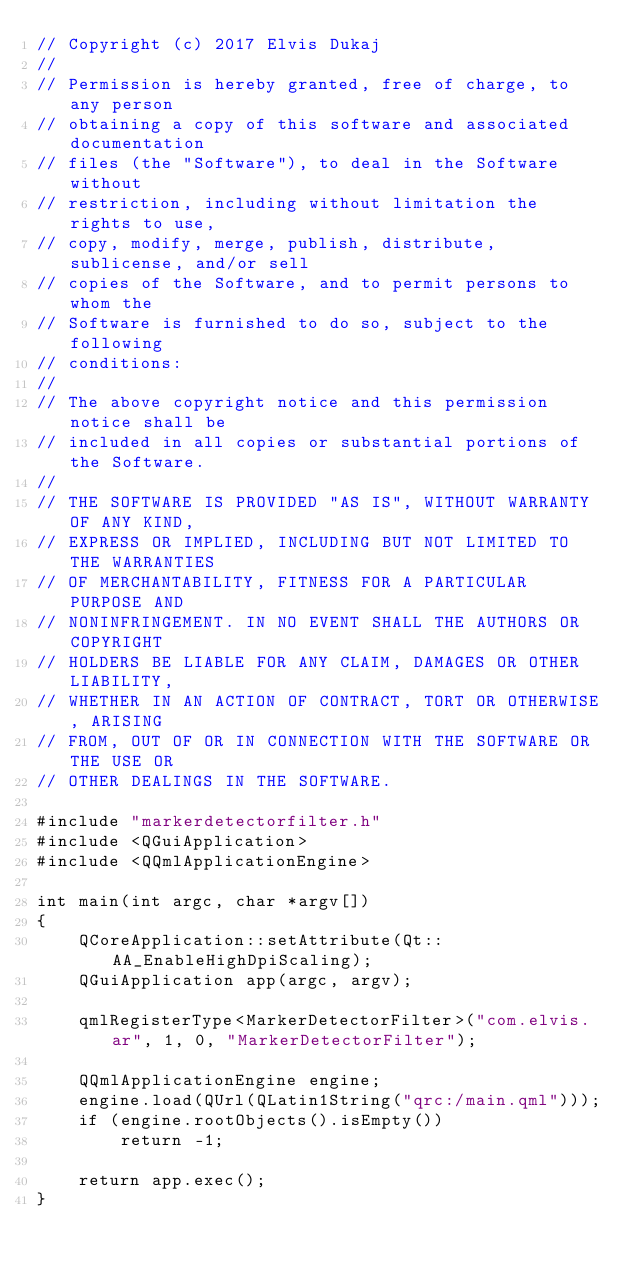<code> <loc_0><loc_0><loc_500><loc_500><_C++_>// Copyright (c) 2017 Elvis Dukaj
// 
// Permission is hereby granted, free of charge, to any person
// obtaining a copy of this software and associated documentation
// files (the "Software"), to deal in the Software without
// restriction, including without limitation the rights to use,
// copy, modify, merge, publish, distribute, sublicense, and/or sell
// copies of the Software, and to permit persons to whom the
// Software is furnished to do so, subject to the following
// conditions:
// 
// The above copyright notice and this permission notice shall be
// included in all copies or substantial portions of the Software.
// 
// THE SOFTWARE IS PROVIDED "AS IS", WITHOUT WARRANTY OF ANY KIND,
// EXPRESS OR IMPLIED, INCLUDING BUT NOT LIMITED TO THE WARRANTIES
// OF MERCHANTABILITY, FITNESS FOR A PARTICULAR PURPOSE AND
// NONINFRINGEMENT. IN NO EVENT SHALL THE AUTHORS OR COPYRIGHT
// HOLDERS BE LIABLE FOR ANY CLAIM, DAMAGES OR OTHER LIABILITY,
// WHETHER IN AN ACTION OF CONTRACT, TORT OR OTHERWISE, ARISING
// FROM, OUT OF OR IN CONNECTION WITH THE SOFTWARE OR THE USE OR
// OTHER DEALINGS IN THE SOFTWARE.

#include "markerdetectorfilter.h"
#include <QGuiApplication>
#include <QQmlApplicationEngine>

int main(int argc, char *argv[])
{
    QCoreApplication::setAttribute(Qt::AA_EnableHighDpiScaling);
    QGuiApplication app(argc, argv);

    qmlRegisterType<MarkerDetectorFilter>("com.elvis.ar", 1, 0, "MarkerDetectorFilter");

    QQmlApplicationEngine engine;
    engine.load(QUrl(QLatin1String("qrc:/main.qml")));
    if (engine.rootObjects().isEmpty())
        return -1;

    return app.exec();
}
</code> 